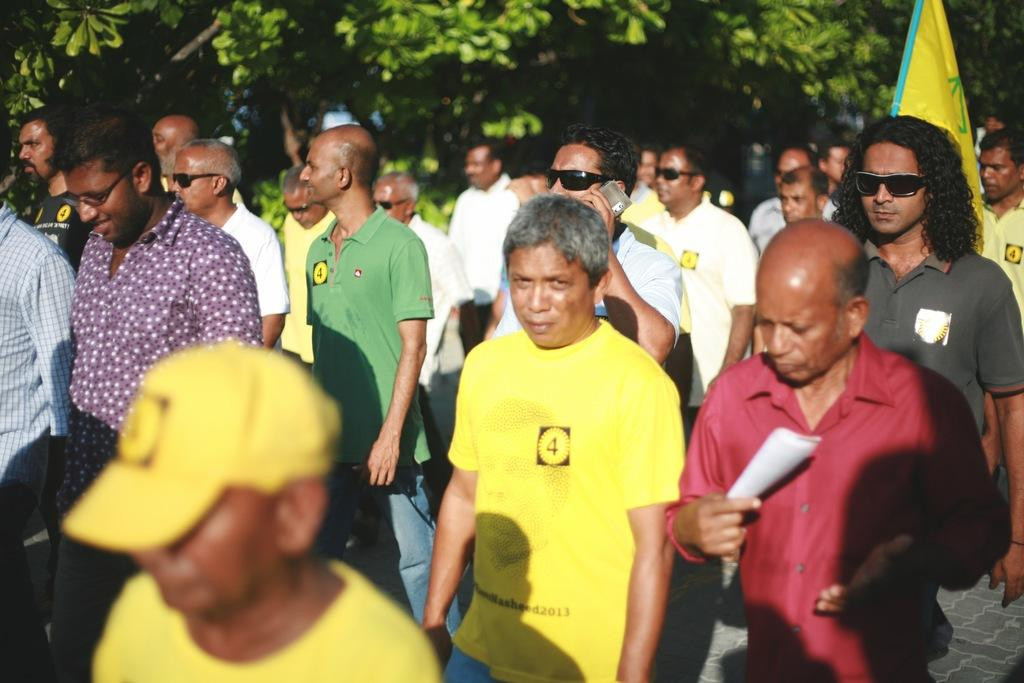How many people are in the image? There are a few people in the image. What is one person doing in the image? One person is holding an object. What can be seen beneath the people in the image? The ground is visible in the image. What is the object in the image that represents a symbol or country? There is a flag in the image. What type of natural scenery is visible in the background of the image? There are trees in the background of the image. What type of apple is being used to trick the person holding the object in the image? There is no apple present in the image, nor is there any indication of a trick being played. 